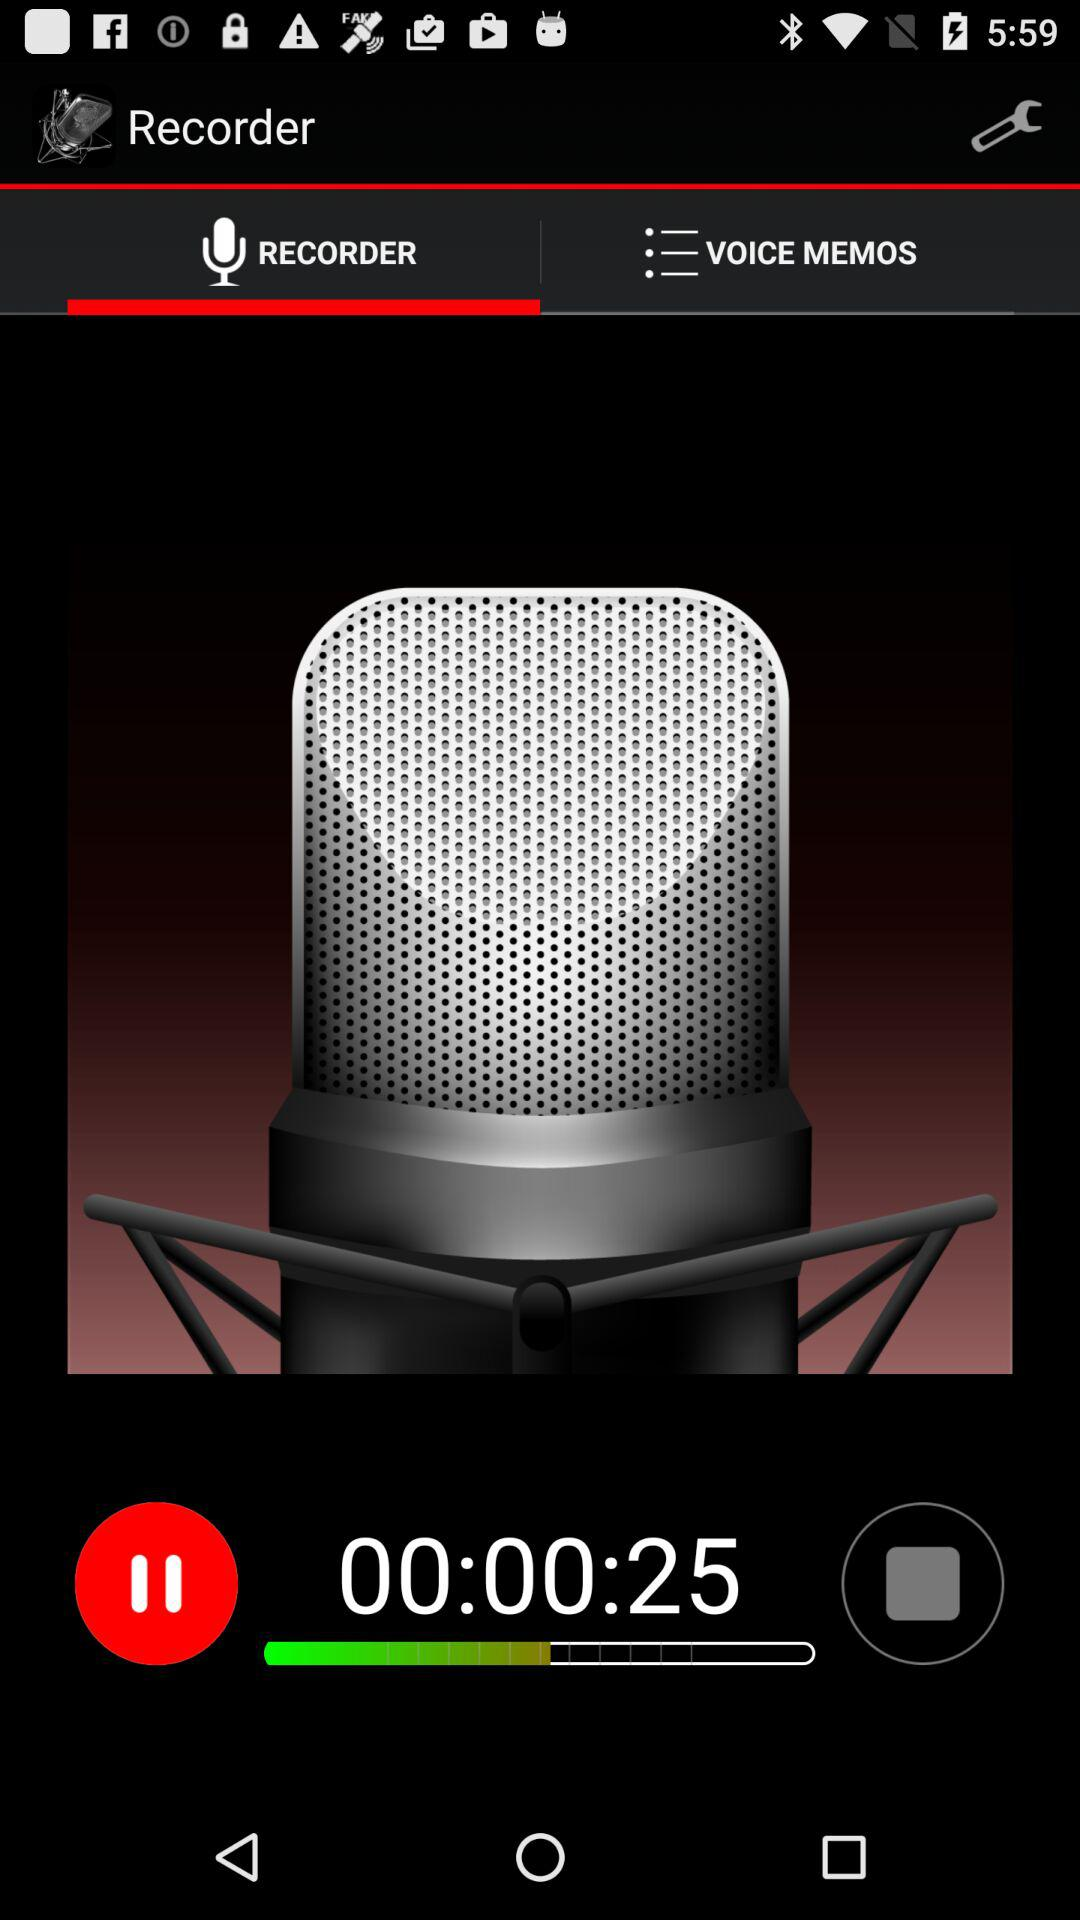How many seconds is the recording?
Answer the question using a single word or phrase. 25 